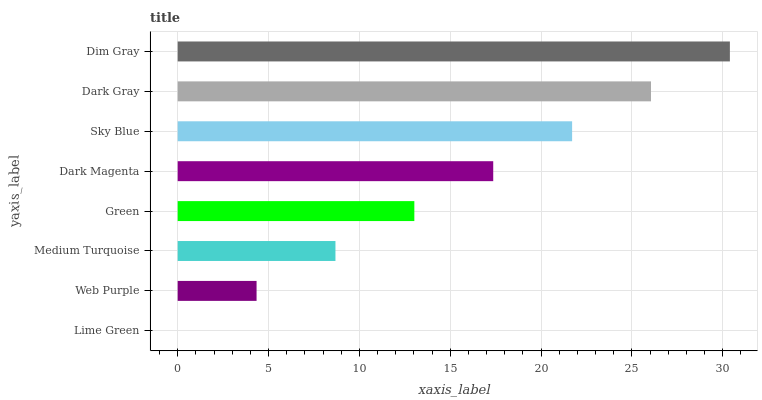Is Lime Green the minimum?
Answer yes or no. Yes. Is Dim Gray the maximum?
Answer yes or no. Yes. Is Web Purple the minimum?
Answer yes or no. No. Is Web Purple the maximum?
Answer yes or no. No. Is Web Purple greater than Lime Green?
Answer yes or no. Yes. Is Lime Green less than Web Purple?
Answer yes or no. Yes. Is Lime Green greater than Web Purple?
Answer yes or no. No. Is Web Purple less than Lime Green?
Answer yes or no. No. Is Dark Magenta the high median?
Answer yes or no. Yes. Is Green the low median?
Answer yes or no. Yes. Is Lime Green the high median?
Answer yes or no. No. Is Sky Blue the low median?
Answer yes or no. No. 